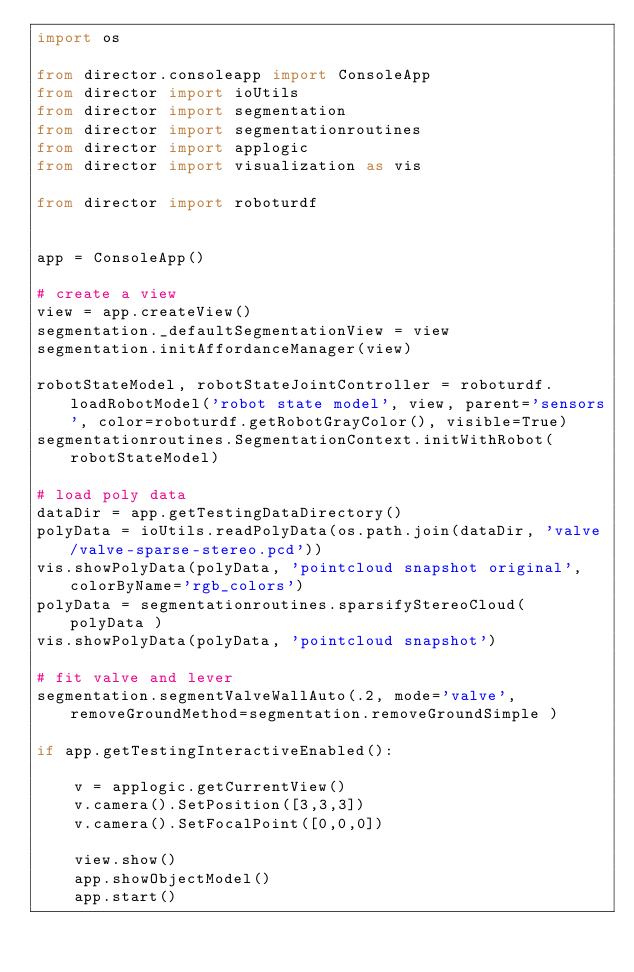<code> <loc_0><loc_0><loc_500><loc_500><_Python_>import os

from director.consoleapp import ConsoleApp
from director import ioUtils
from director import segmentation
from director import segmentationroutines
from director import applogic
from director import visualization as vis

from director import roboturdf


app = ConsoleApp()

# create a view
view = app.createView()
segmentation._defaultSegmentationView = view
segmentation.initAffordanceManager(view)

robotStateModel, robotStateJointController = roboturdf.loadRobotModel('robot state model', view, parent='sensors', color=roboturdf.getRobotGrayColor(), visible=True)
segmentationroutines.SegmentationContext.initWithRobot(robotStateModel)

# load poly data
dataDir = app.getTestingDataDirectory()
polyData = ioUtils.readPolyData(os.path.join(dataDir, 'valve/valve-sparse-stereo.pcd'))
vis.showPolyData(polyData, 'pointcloud snapshot original', colorByName='rgb_colors')
polyData = segmentationroutines.sparsifyStereoCloud( polyData )
vis.showPolyData(polyData, 'pointcloud snapshot')

# fit valve and lever
segmentation.segmentValveWallAuto(.2, mode='valve', removeGroundMethod=segmentation.removeGroundSimple )

if app.getTestingInteractiveEnabled():

    v = applogic.getCurrentView()
    v.camera().SetPosition([3,3,3])
    v.camera().SetFocalPoint([0,0,0])

    view.show()
    app.showObjectModel()
    app.start()
</code> 